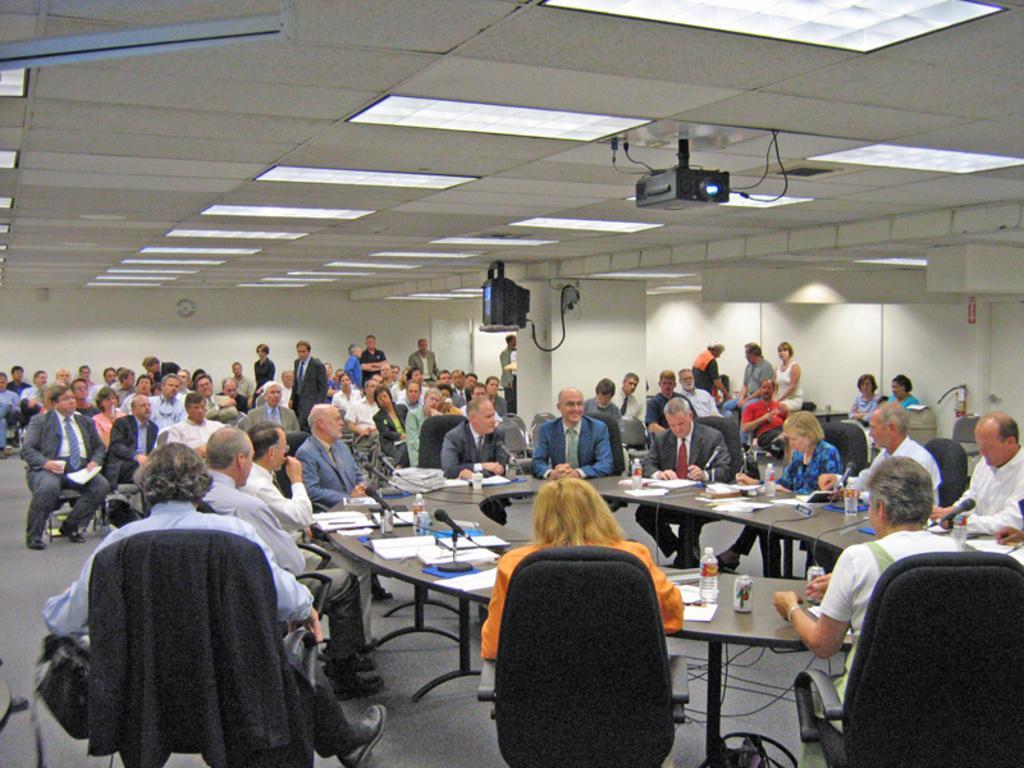Please provide a concise description of this image. Here we can see that a group of people are sitting on the chair, and in front her is the table and water bottle and some other objects on it, and here is the pillar, and here is the roof. 